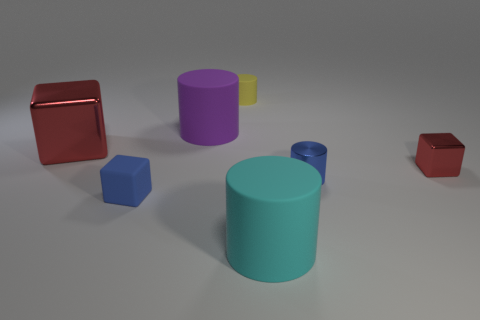Subtract all gray spheres. How many red cubes are left? 2 Subtract all cyan matte cylinders. How many cylinders are left? 3 Add 2 tiny cubes. How many objects exist? 9 Subtract all purple cylinders. How many cylinders are left? 3 Subtract all blocks. How many objects are left? 4 Subtract all metallic things. Subtract all yellow cylinders. How many objects are left? 3 Add 1 small metal blocks. How many small metal blocks are left? 2 Add 2 green shiny cylinders. How many green shiny cylinders exist? 2 Subtract 0 purple cubes. How many objects are left? 7 Subtract all brown cubes. Subtract all gray balls. How many cubes are left? 3 